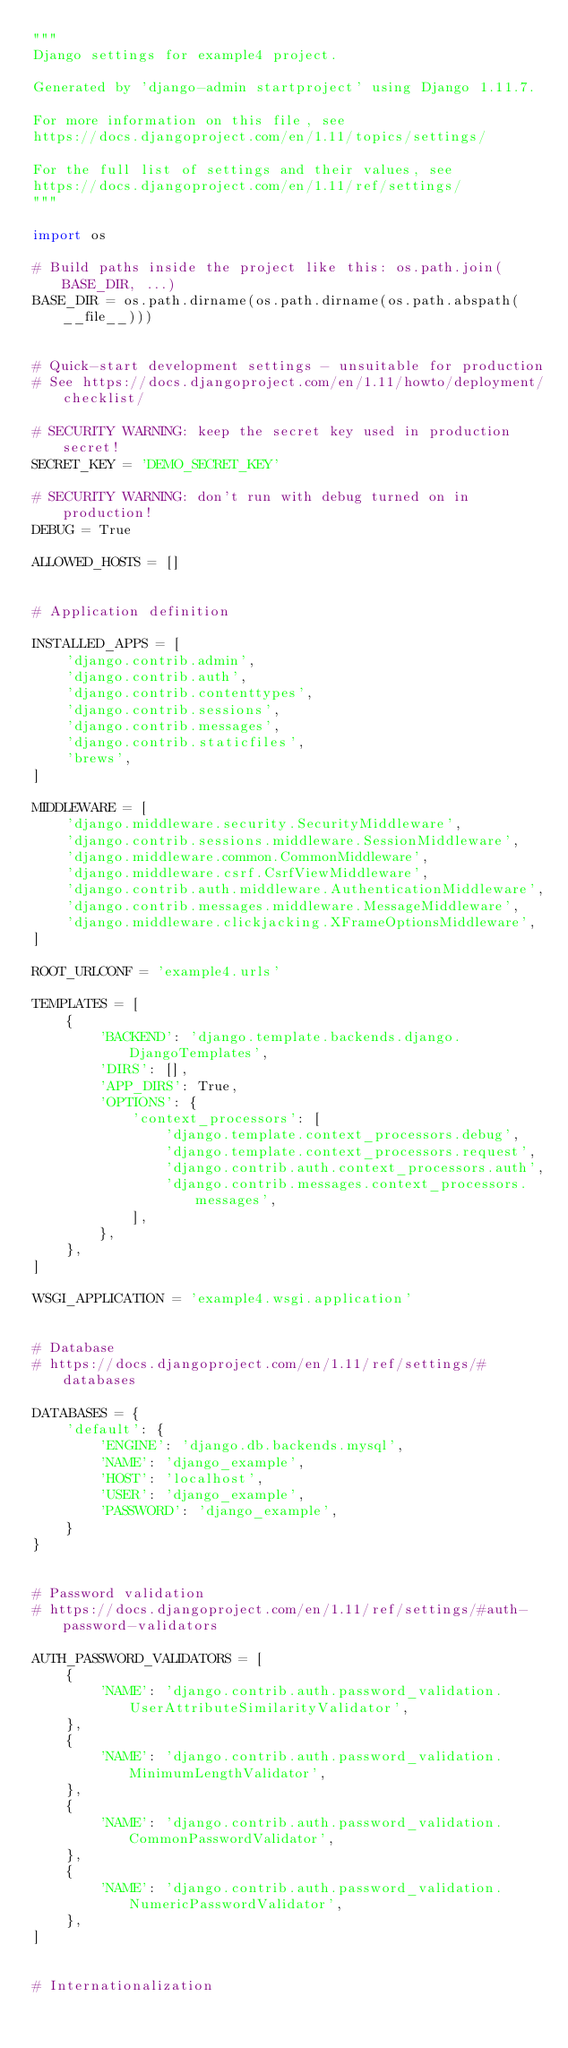Convert code to text. <code><loc_0><loc_0><loc_500><loc_500><_Python_>"""
Django settings for example4 project.

Generated by 'django-admin startproject' using Django 1.11.7.

For more information on this file, see
https://docs.djangoproject.com/en/1.11/topics/settings/

For the full list of settings and their values, see
https://docs.djangoproject.com/en/1.11/ref/settings/
"""

import os

# Build paths inside the project like this: os.path.join(BASE_DIR, ...)
BASE_DIR = os.path.dirname(os.path.dirname(os.path.abspath(__file__)))


# Quick-start development settings - unsuitable for production
# See https://docs.djangoproject.com/en/1.11/howto/deployment/checklist/

# SECURITY WARNING: keep the secret key used in production secret!
SECRET_KEY = 'DEMO_SECRET_KEY'

# SECURITY WARNING: don't run with debug turned on in production!
DEBUG = True

ALLOWED_HOSTS = []


# Application definition

INSTALLED_APPS = [
    'django.contrib.admin',
    'django.contrib.auth',
    'django.contrib.contenttypes',
    'django.contrib.sessions',
    'django.contrib.messages',
    'django.contrib.staticfiles',
    'brews',
]

MIDDLEWARE = [
    'django.middleware.security.SecurityMiddleware',
    'django.contrib.sessions.middleware.SessionMiddleware',
    'django.middleware.common.CommonMiddleware',
    'django.middleware.csrf.CsrfViewMiddleware',
    'django.contrib.auth.middleware.AuthenticationMiddleware',
    'django.contrib.messages.middleware.MessageMiddleware',
    'django.middleware.clickjacking.XFrameOptionsMiddleware',
]

ROOT_URLCONF = 'example4.urls'

TEMPLATES = [
    {
        'BACKEND': 'django.template.backends.django.DjangoTemplates',
        'DIRS': [],
        'APP_DIRS': True,
        'OPTIONS': {
            'context_processors': [
                'django.template.context_processors.debug',
                'django.template.context_processors.request',
                'django.contrib.auth.context_processors.auth',
                'django.contrib.messages.context_processors.messages',
            ],
        },
    },
]

WSGI_APPLICATION = 'example4.wsgi.application'


# Database
# https://docs.djangoproject.com/en/1.11/ref/settings/#databases

DATABASES = {
    'default': {
        'ENGINE': 'django.db.backends.mysql',
        'NAME': 'django_example',
        'HOST': 'localhost',
        'USER': 'django_example',
        'PASSWORD': 'django_example',
    }
}


# Password validation
# https://docs.djangoproject.com/en/1.11/ref/settings/#auth-password-validators

AUTH_PASSWORD_VALIDATORS = [
    {
        'NAME': 'django.contrib.auth.password_validation.UserAttributeSimilarityValidator',
    },
    {
        'NAME': 'django.contrib.auth.password_validation.MinimumLengthValidator',
    },
    {
        'NAME': 'django.contrib.auth.password_validation.CommonPasswordValidator',
    },
    {
        'NAME': 'django.contrib.auth.password_validation.NumericPasswordValidator',
    },
]


# Internationalization</code> 